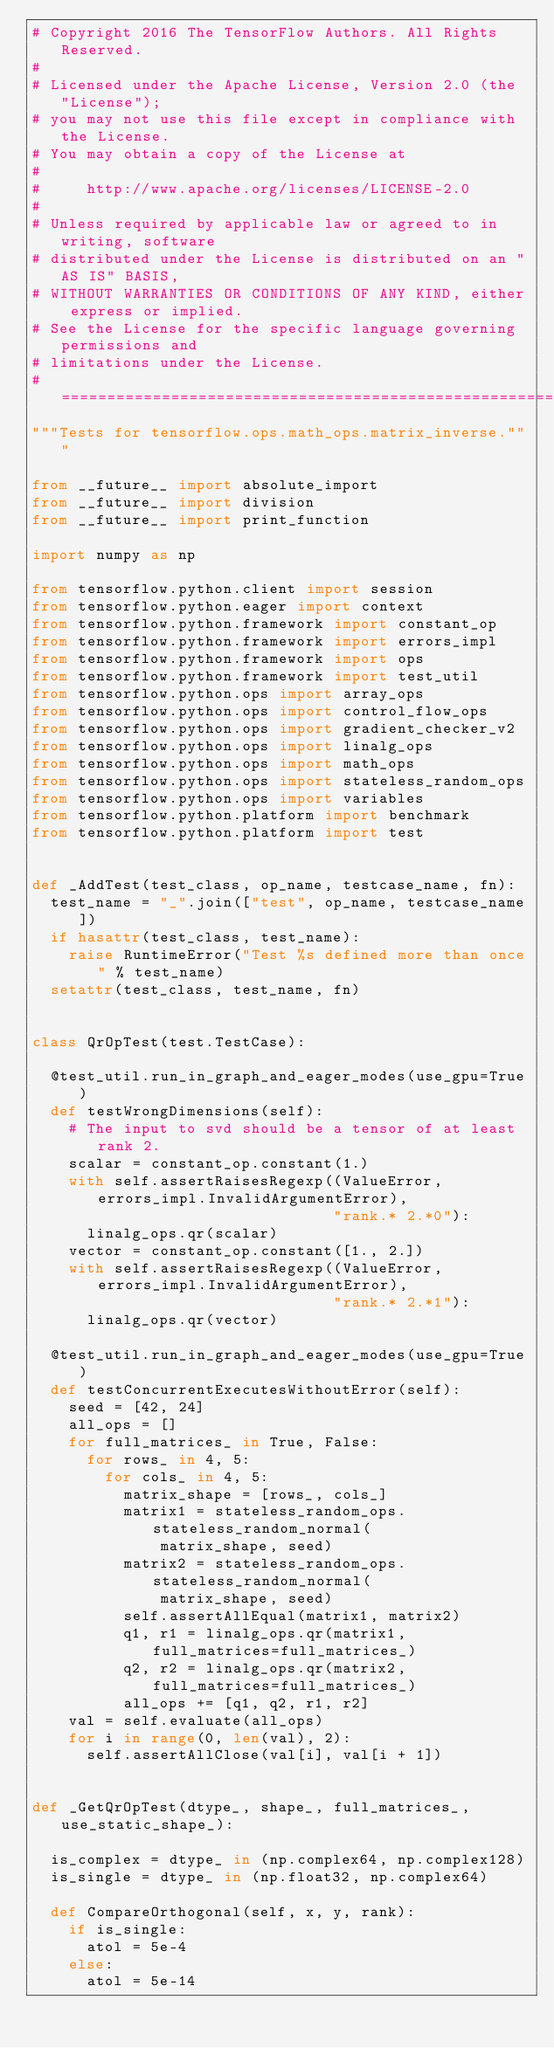Convert code to text. <code><loc_0><loc_0><loc_500><loc_500><_Python_># Copyright 2016 The TensorFlow Authors. All Rights Reserved.
#
# Licensed under the Apache License, Version 2.0 (the "License");
# you may not use this file except in compliance with the License.
# You may obtain a copy of the License at
#
#     http://www.apache.org/licenses/LICENSE-2.0
#
# Unless required by applicable law or agreed to in writing, software
# distributed under the License is distributed on an "AS IS" BASIS,
# WITHOUT WARRANTIES OR CONDITIONS OF ANY KIND, either express or implied.
# See the License for the specific language governing permissions and
# limitations under the License.
# ==============================================================================
"""Tests for tensorflow.ops.math_ops.matrix_inverse."""

from __future__ import absolute_import
from __future__ import division
from __future__ import print_function

import numpy as np

from tensorflow.python.client import session
from tensorflow.python.eager import context
from tensorflow.python.framework import constant_op
from tensorflow.python.framework import errors_impl
from tensorflow.python.framework import ops
from tensorflow.python.framework import test_util
from tensorflow.python.ops import array_ops
from tensorflow.python.ops import control_flow_ops
from tensorflow.python.ops import gradient_checker_v2
from tensorflow.python.ops import linalg_ops
from tensorflow.python.ops import math_ops
from tensorflow.python.ops import stateless_random_ops
from tensorflow.python.ops import variables
from tensorflow.python.platform import benchmark
from tensorflow.python.platform import test


def _AddTest(test_class, op_name, testcase_name, fn):
  test_name = "_".join(["test", op_name, testcase_name])
  if hasattr(test_class, test_name):
    raise RuntimeError("Test %s defined more than once" % test_name)
  setattr(test_class, test_name, fn)


class QrOpTest(test.TestCase):

  @test_util.run_in_graph_and_eager_modes(use_gpu=True)
  def testWrongDimensions(self):
    # The input to svd should be a tensor of at least rank 2.
    scalar = constant_op.constant(1.)
    with self.assertRaisesRegexp((ValueError, errors_impl.InvalidArgumentError),
                                 "rank.* 2.*0"):
      linalg_ops.qr(scalar)
    vector = constant_op.constant([1., 2.])
    with self.assertRaisesRegexp((ValueError, errors_impl.InvalidArgumentError),
                                 "rank.* 2.*1"):
      linalg_ops.qr(vector)

  @test_util.run_in_graph_and_eager_modes(use_gpu=True)
  def testConcurrentExecutesWithoutError(self):
    seed = [42, 24]
    all_ops = []
    for full_matrices_ in True, False:
      for rows_ in 4, 5:
        for cols_ in 4, 5:
          matrix_shape = [rows_, cols_]
          matrix1 = stateless_random_ops.stateless_random_normal(
              matrix_shape, seed)
          matrix2 = stateless_random_ops.stateless_random_normal(
              matrix_shape, seed)
          self.assertAllEqual(matrix1, matrix2)
          q1, r1 = linalg_ops.qr(matrix1, full_matrices=full_matrices_)
          q2, r2 = linalg_ops.qr(matrix2, full_matrices=full_matrices_)
          all_ops += [q1, q2, r1, r2]
    val = self.evaluate(all_ops)
    for i in range(0, len(val), 2):
      self.assertAllClose(val[i], val[i + 1])


def _GetQrOpTest(dtype_, shape_, full_matrices_, use_static_shape_):

  is_complex = dtype_ in (np.complex64, np.complex128)
  is_single = dtype_ in (np.float32, np.complex64)

  def CompareOrthogonal(self, x, y, rank):
    if is_single:
      atol = 5e-4
    else:
      atol = 5e-14</code> 